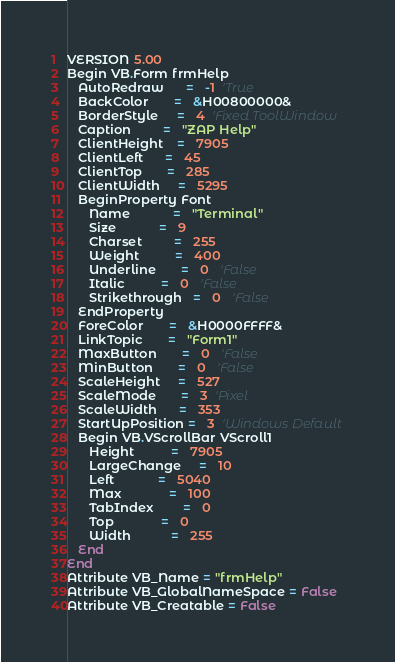Convert code to text. <code><loc_0><loc_0><loc_500><loc_500><_VisualBasic_>VERSION 5.00
Begin VB.Form frmHelp 
   AutoRedraw      =   -1  'True
   BackColor       =   &H00800000&
   BorderStyle     =   4  'Fixed ToolWindow
   Caption         =   "ZAP Help"
   ClientHeight    =   7905
   ClientLeft      =   45
   ClientTop       =   285
   ClientWidth     =   5295
   BeginProperty Font 
      Name            =   "Terminal"
      Size            =   9
      Charset         =   255
      Weight          =   400
      Underline       =   0   'False
      Italic          =   0   'False
      Strikethrough   =   0   'False
   EndProperty
   ForeColor       =   &H0000FFFF&
   LinkTopic       =   "Form1"
   MaxButton       =   0   'False
   MinButton       =   0   'False
   ScaleHeight     =   527
   ScaleMode       =   3  'Pixel
   ScaleWidth      =   353
   StartUpPosition =   3  'Windows Default
   Begin VB.VScrollBar VScroll1 
      Height          =   7905
      LargeChange     =   10
      Left            =   5040
      Max             =   100
      TabIndex        =   0
      Top             =   0
      Width           =   255
   End
End
Attribute VB_Name = "frmHelp"
Attribute VB_GlobalNameSpace = False
Attribute VB_Creatable = False</code> 